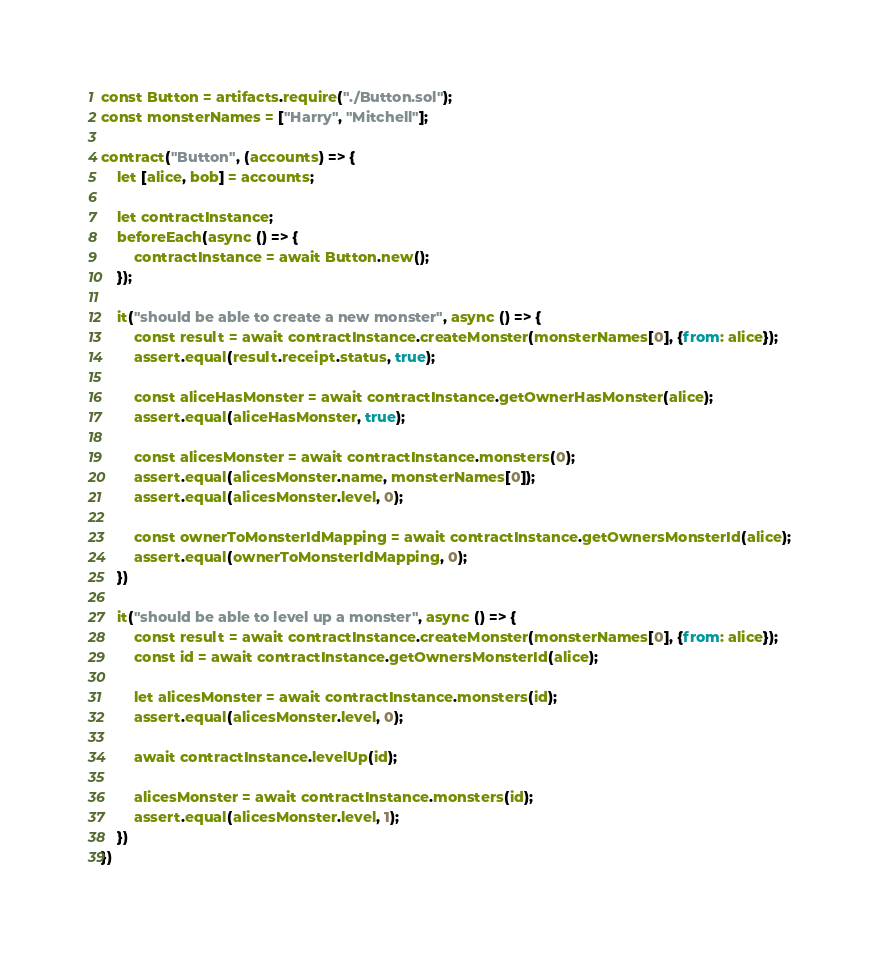Convert code to text. <code><loc_0><loc_0><loc_500><loc_500><_JavaScript_>const Button = artifacts.require("./Button.sol");
const monsterNames = ["Harry", "Mitchell"];

contract("Button", (accounts) => {
    let [alice, bob] = accounts;

    let contractInstance;
    beforeEach(async () => {
        contractInstance = await Button.new();
    });

    it("should be able to create a new monster", async () => {
        const result = await contractInstance.createMonster(monsterNames[0], {from: alice});
        assert.equal(result.receipt.status, true);

        const aliceHasMonster = await contractInstance.getOwnerHasMonster(alice);
        assert.equal(aliceHasMonster, true);

        const alicesMonster = await contractInstance.monsters(0);
        assert.equal(alicesMonster.name, monsterNames[0]);
        assert.equal(alicesMonster.level, 0);
        
        const ownerToMonsterIdMapping = await contractInstance.getOwnersMonsterId(alice);
        assert.equal(ownerToMonsterIdMapping, 0);
    })

    it("should be able to level up a monster", async () => {
        const result = await contractInstance.createMonster(monsterNames[0], {from: alice});
        const id = await contractInstance.getOwnersMonsterId(alice);

        let alicesMonster = await contractInstance.monsters(id);
        assert.equal(alicesMonster.level, 0);

        await contractInstance.levelUp(id);

        alicesMonster = await contractInstance.monsters(id);
        assert.equal(alicesMonster.level, 1);
    })
})</code> 